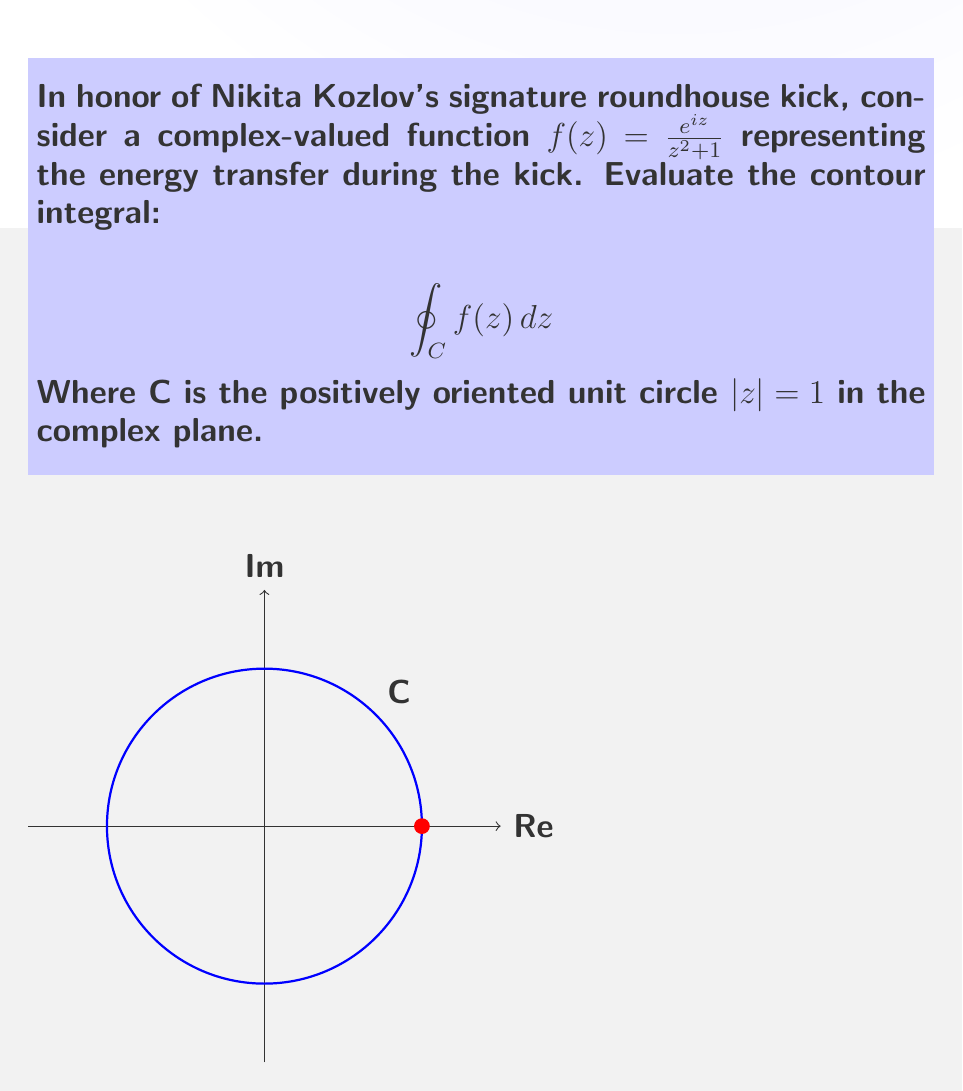Show me your answer to this math problem. Let's approach this step-by-step using the Residue Theorem:

1) First, we need to find the singularities of $f(z)$ inside the unit circle.
   The poles are at $z = \pm i$, but only $z = i$ is inside the unit circle.

2) Calculate the residue at $z = i$:
   $$\text{Res}(f, i) = \lim_{z \to i} (z-i)f(z) = \lim_{z \to i} \frac{(z-i)e^{iz}}{z^2 + 1}$$

3) Using L'Hôpital's rule:
   $$\text{Res}(f, i) = \lim_{z \to i} \frac{e^{iz} + (z-i)ie^{iz}}{2z} = \frac{e^{-1}}{2i}$$

4) By the Residue Theorem:
   $$\oint_C f(z) dz = 2\pi i \cdot \text{Res}(f, i) = 2\pi i \cdot \frac{e^{-1}}{2i} = \pi e^{-1}$$

This result represents the total energy transfer during Kozlov's roundhouse kick, modeled by our complex function.
Answer: $\pi e^{-1}$ 